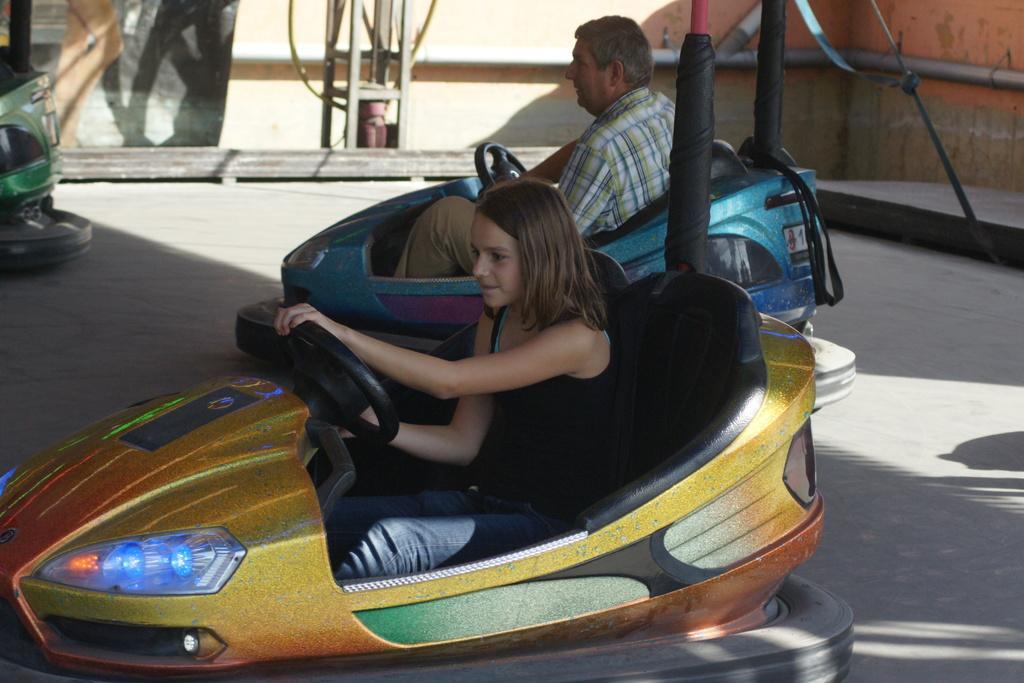What is the girl doing in the image? The girl is driving a toy car. What is the girl wearing in the image? The girl is wearing a black dress and jeans. What is the man doing in the image? The man is driving another toy car. What can be seen on the right side of the image? There is a wall on the right side of the image. What type of birds can be seen flying near the wall in the image? There are no birds visible in the image; it only shows a girl and a man driving toy cars. Is there a cobweb present on the wall in the image? There is no mention of a cobweb in the provided facts, so we cannot determine its presence in the image. 